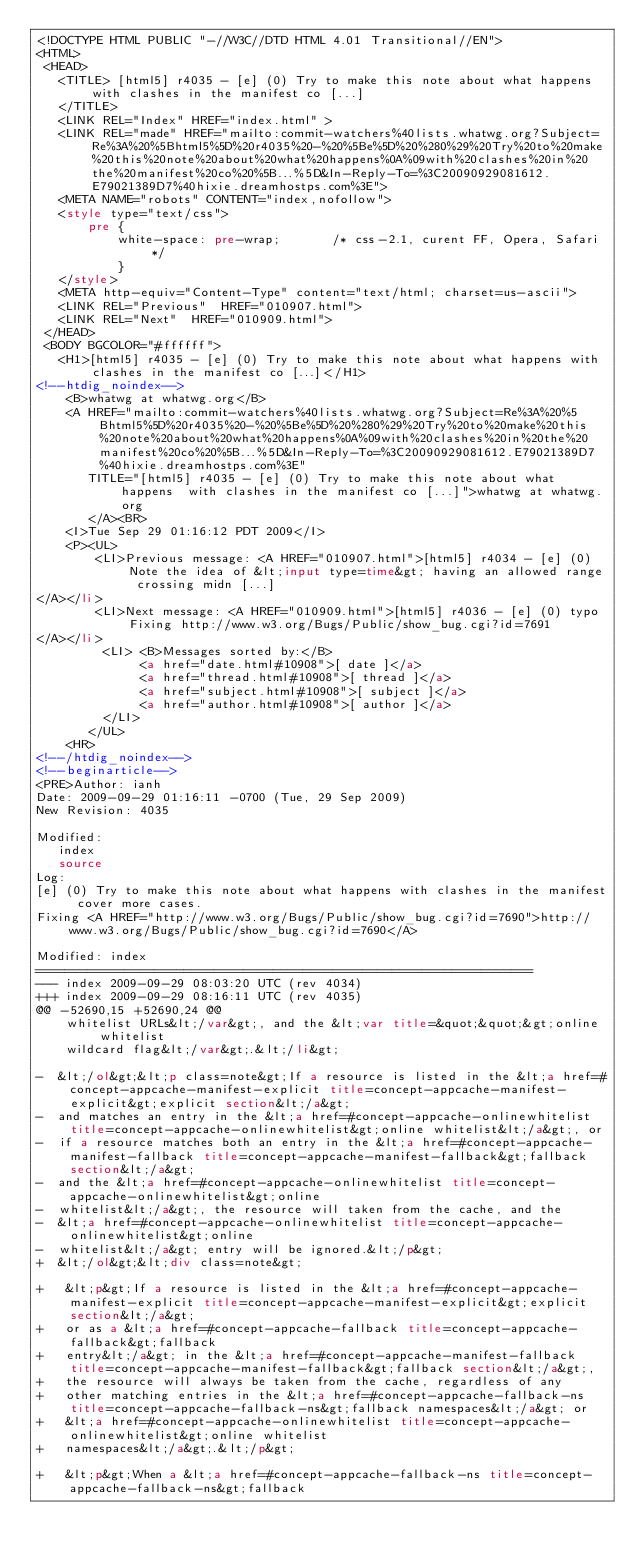<code> <loc_0><loc_0><loc_500><loc_500><_HTML_><!DOCTYPE HTML PUBLIC "-//W3C//DTD HTML 4.01 Transitional//EN">
<HTML>
 <HEAD>
   <TITLE> [html5] r4035 - [e] (0) Try to make this note about what happens	with clashes in the manifest co [...]
   </TITLE>
   <LINK REL="Index" HREF="index.html" >
   <LINK REL="made" HREF="mailto:commit-watchers%40lists.whatwg.org?Subject=Re%3A%20%5Bhtml5%5D%20r4035%20-%20%5Be%5D%20%280%29%20Try%20to%20make%20this%20note%20about%20what%20happens%0A%09with%20clashes%20in%20the%20manifest%20co%20%5B...%5D&In-Reply-To=%3C20090929081612.E79021389D7%40hixie.dreamhostps.com%3E">
   <META NAME="robots" CONTENT="index,nofollow">
   <style type="text/css">
       pre {
           white-space: pre-wrap;       /* css-2.1, curent FF, Opera, Safari */
           }
   </style>
   <META http-equiv="Content-Type" content="text/html; charset=us-ascii">
   <LINK REL="Previous"  HREF="010907.html">
   <LINK REL="Next"  HREF="010909.html">
 </HEAD>
 <BODY BGCOLOR="#ffffff">
   <H1>[html5] r4035 - [e] (0) Try to make this note about what happens	with clashes in the manifest co [...]</H1>
<!--htdig_noindex-->
    <B>whatwg at whatwg.org</B> 
    <A HREF="mailto:commit-watchers%40lists.whatwg.org?Subject=Re%3A%20%5Bhtml5%5D%20r4035%20-%20%5Be%5D%20%280%29%20Try%20to%20make%20this%20note%20about%20what%20happens%0A%09with%20clashes%20in%20the%20manifest%20co%20%5B...%5D&In-Reply-To=%3C20090929081612.E79021389D7%40hixie.dreamhostps.com%3E"
       TITLE="[html5] r4035 - [e] (0) Try to make this note about what happens	with clashes in the manifest co [...]">whatwg at whatwg.org
       </A><BR>
    <I>Tue Sep 29 01:16:12 PDT 2009</I>
    <P><UL>
        <LI>Previous message: <A HREF="010907.html">[html5] r4034 - [e] (0) Note the idea of &lt;input type=time&gt; having	an allowed range crossing midn [...]
</A></li>
        <LI>Next message: <A HREF="010909.html">[html5] r4036 - [e] (0) typo Fixing	http://www.w3.org/Bugs/Public/show_bug.cgi?id=7691
</A></li>
         <LI> <B>Messages sorted by:</B> 
              <a href="date.html#10908">[ date ]</a>
              <a href="thread.html#10908">[ thread ]</a>
              <a href="subject.html#10908">[ subject ]</a>
              <a href="author.html#10908">[ author ]</a>
         </LI>
       </UL>
    <HR>  
<!--/htdig_noindex-->
<!--beginarticle-->
<PRE>Author: ianh
Date: 2009-09-29 01:16:11 -0700 (Tue, 29 Sep 2009)
New Revision: 4035

Modified:
   index
   source
Log:
[e] (0) Try to make this note about what happens with clashes in the manifest cover more cases.
Fixing <A HREF="http://www.w3.org/Bugs/Public/show_bug.cgi?id=7690">http://www.w3.org/Bugs/Public/show_bug.cgi?id=7690</A>

Modified: index
===================================================================
--- index	2009-09-29 08:03:20 UTC (rev 4034)
+++ index	2009-09-29 08:16:11 UTC (rev 4035)
@@ -52690,15 +52690,24 @@
    whitelist URLs&lt;/var&gt;, and the &lt;var title=&quot;&quot;&gt;online whitelist
    wildcard flag&lt;/var&gt;.&lt;/li&gt;
 
-  &lt;/ol&gt;&lt;p class=note&gt;If a resource is listed in the &lt;a href=#concept-appcache-manifest-explicit title=concept-appcache-manifest-explicit&gt;explicit section&lt;/a&gt;
-  and matches an entry in the &lt;a href=#concept-appcache-onlinewhitelist title=concept-appcache-onlinewhitelist&gt;online whitelist&lt;/a&gt;, or
-  if a resource matches both an entry in the &lt;a href=#concept-appcache-manifest-fallback title=concept-appcache-manifest-fallback&gt;fallback section&lt;/a&gt;
-  and the &lt;a href=#concept-appcache-onlinewhitelist title=concept-appcache-onlinewhitelist&gt;online
-  whitelist&lt;/a&gt;, the resource will taken from the cache, and the
-  &lt;a href=#concept-appcache-onlinewhitelist title=concept-appcache-onlinewhitelist&gt;online
-  whitelist&lt;/a&gt; entry will be ignored.&lt;/p&gt;
+  &lt;/ol&gt;&lt;div class=note&gt;
 
+   &lt;p&gt;If a resource is listed in the &lt;a href=#concept-appcache-manifest-explicit title=concept-appcache-manifest-explicit&gt;explicit section&lt;/a&gt;
+   or as a &lt;a href=#concept-appcache-fallback title=concept-appcache-fallback&gt;fallback
+   entry&lt;/a&gt; in the &lt;a href=#concept-appcache-manifest-fallback title=concept-appcache-manifest-fallback&gt;fallback section&lt;/a&gt;,
+   the resource will always be taken from the cache, regardless of any
+   other matching entries in the &lt;a href=#concept-appcache-fallback-ns title=concept-appcache-fallback-ns&gt;fallback namespaces&lt;/a&gt; or
+   &lt;a href=#concept-appcache-onlinewhitelist title=concept-appcache-onlinewhitelist&gt;online whitelist
+   namespaces&lt;/a&gt;.&lt;/p&gt;
 
+   &lt;p&gt;When a &lt;a href=#concept-appcache-fallback-ns title=concept-appcache-fallback-ns&gt;fallback</code> 